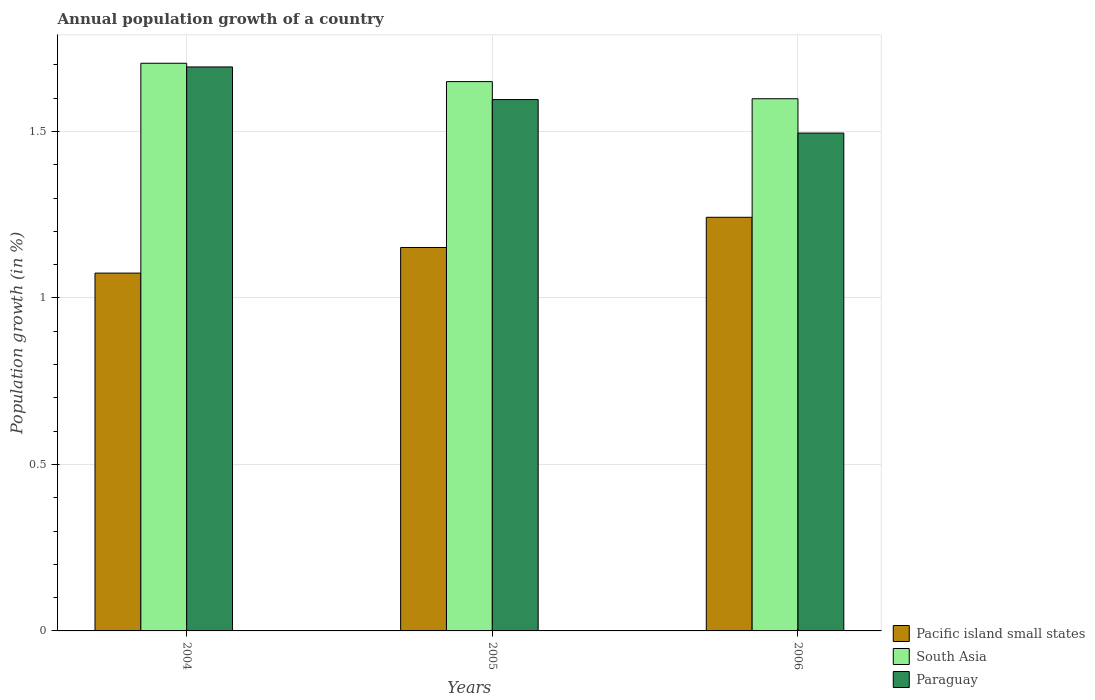How many groups of bars are there?
Make the answer very short. 3. Are the number of bars per tick equal to the number of legend labels?
Offer a terse response. Yes. Are the number of bars on each tick of the X-axis equal?
Your answer should be compact. Yes. How many bars are there on the 2nd tick from the left?
Offer a very short reply. 3. What is the label of the 1st group of bars from the left?
Your response must be concise. 2004. What is the annual population growth in Pacific island small states in 2005?
Keep it short and to the point. 1.15. Across all years, what is the maximum annual population growth in Pacific island small states?
Offer a very short reply. 1.24. Across all years, what is the minimum annual population growth in South Asia?
Offer a terse response. 1.6. What is the total annual population growth in Paraguay in the graph?
Keep it short and to the point. 4.78. What is the difference between the annual population growth in South Asia in 2004 and that in 2006?
Your response must be concise. 0.11. What is the difference between the annual population growth in Paraguay in 2005 and the annual population growth in Pacific island small states in 2006?
Your answer should be very brief. 0.35. What is the average annual population growth in Paraguay per year?
Keep it short and to the point. 1.59. In the year 2005, what is the difference between the annual population growth in Pacific island small states and annual population growth in Paraguay?
Offer a terse response. -0.44. What is the ratio of the annual population growth in Paraguay in 2005 to that in 2006?
Your answer should be compact. 1.07. What is the difference between the highest and the second highest annual population growth in Paraguay?
Your response must be concise. 0.1. What is the difference between the highest and the lowest annual population growth in Pacific island small states?
Offer a very short reply. 0.17. In how many years, is the annual population growth in Paraguay greater than the average annual population growth in Paraguay taken over all years?
Make the answer very short. 2. Is the sum of the annual population growth in Paraguay in 2004 and 2005 greater than the maximum annual population growth in Pacific island small states across all years?
Make the answer very short. Yes. What does the 3rd bar from the left in 2006 represents?
Offer a terse response. Paraguay. Is it the case that in every year, the sum of the annual population growth in South Asia and annual population growth in Paraguay is greater than the annual population growth in Pacific island small states?
Your response must be concise. Yes. How many bars are there?
Offer a terse response. 9. Are all the bars in the graph horizontal?
Provide a short and direct response. No. How many years are there in the graph?
Offer a terse response. 3. Where does the legend appear in the graph?
Offer a terse response. Bottom right. How are the legend labels stacked?
Your response must be concise. Vertical. What is the title of the graph?
Make the answer very short. Annual population growth of a country. What is the label or title of the X-axis?
Offer a terse response. Years. What is the label or title of the Y-axis?
Keep it short and to the point. Population growth (in %). What is the Population growth (in %) in Pacific island small states in 2004?
Your answer should be compact. 1.07. What is the Population growth (in %) of South Asia in 2004?
Your answer should be very brief. 1.7. What is the Population growth (in %) in Paraguay in 2004?
Your answer should be very brief. 1.69. What is the Population growth (in %) in Pacific island small states in 2005?
Give a very brief answer. 1.15. What is the Population growth (in %) of South Asia in 2005?
Your answer should be compact. 1.65. What is the Population growth (in %) in Paraguay in 2005?
Give a very brief answer. 1.6. What is the Population growth (in %) in Pacific island small states in 2006?
Ensure brevity in your answer.  1.24. What is the Population growth (in %) in South Asia in 2006?
Give a very brief answer. 1.6. What is the Population growth (in %) in Paraguay in 2006?
Give a very brief answer. 1.5. Across all years, what is the maximum Population growth (in %) in Pacific island small states?
Your answer should be compact. 1.24. Across all years, what is the maximum Population growth (in %) in South Asia?
Provide a succinct answer. 1.7. Across all years, what is the maximum Population growth (in %) in Paraguay?
Offer a terse response. 1.69. Across all years, what is the minimum Population growth (in %) in Pacific island small states?
Offer a terse response. 1.07. Across all years, what is the minimum Population growth (in %) in South Asia?
Offer a very short reply. 1.6. Across all years, what is the minimum Population growth (in %) of Paraguay?
Your answer should be compact. 1.5. What is the total Population growth (in %) of Pacific island small states in the graph?
Provide a succinct answer. 3.47. What is the total Population growth (in %) in South Asia in the graph?
Your answer should be compact. 4.95. What is the total Population growth (in %) of Paraguay in the graph?
Provide a succinct answer. 4.78. What is the difference between the Population growth (in %) in Pacific island small states in 2004 and that in 2005?
Give a very brief answer. -0.08. What is the difference between the Population growth (in %) in South Asia in 2004 and that in 2005?
Provide a succinct answer. 0.06. What is the difference between the Population growth (in %) in Paraguay in 2004 and that in 2005?
Offer a very short reply. 0.1. What is the difference between the Population growth (in %) in Pacific island small states in 2004 and that in 2006?
Offer a very short reply. -0.17. What is the difference between the Population growth (in %) in South Asia in 2004 and that in 2006?
Give a very brief answer. 0.11. What is the difference between the Population growth (in %) in Paraguay in 2004 and that in 2006?
Ensure brevity in your answer.  0.2. What is the difference between the Population growth (in %) of Pacific island small states in 2005 and that in 2006?
Provide a succinct answer. -0.09. What is the difference between the Population growth (in %) in South Asia in 2005 and that in 2006?
Keep it short and to the point. 0.05. What is the difference between the Population growth (in %) in Paraguay in 2005 and that in 2006?
Your response must be concise. 0.1. What is the difference between the Population growth (in %) of Pacific island small states in 2004 and the Population growth (in %) of South Asia in 2005?
Offer a terse response. -0.58. What is the difference between the Population growth (in %) of Pacific island small states in 2004 and the Population growth (in %) of Paraguay in 2005?
Ensure brevity in your answer.  -0.52. What is the difference between the Population growth (in %) in South Asia in 2004 and the Population growth (in %) in Paraguay in 2005?
Your response must be concise. 0.11. What is the difference between the Population growth (in %) in Pacific island small states in 2004 and the Population growth (in %) in South Asia in 2006?
Keep it short and to the point. -0.52. What is the difference between the Population growth (in %) in Pacific island small states in 2004 and the Population growth (in %) in Paraguay in 2006?
Keep it short and to the point. -0.42. What is the difference between the Population growth (in %) in South Asia in 2004 and the Population growth (in %) in Paraguay in 2006?
Your response must be concise. 0.21. What is the difference between the Population growth (in %) of Pacific island small states in 2005 and the Population growth (in %) of South Asia in 2006?
Your response must be concise. -0.45. What is the difference between the Population growth (in %) in Pacific island small states in 2005 and the Population growth (in %) in Paraguay in 2006?
Keep it short and to the point. -0.34. What is the difference between the Population growth (in %) in South Asia in 2005 and the Population growth (in %) in Paraguay in 2006?
Your answer should be compact. 0.15. What is the average Population growth (in %) of Pacific island small states per year?
Ensure brevity in your answer.  1.16. What is the average Population growth (in %) in South Asia per year?
Provide a short and direct response. 1.65. What is the average Population growth (in %) in Paraguay per year?
Keep it short and to the point. 1.59. In the year 2004, what is the difference between the Population growth (in %) in Pacific island small states and Population growth (in %) in South Asia?
Ensure brevity in your answer.  -0.63. In the year 2004, what is the difference between the Population growth (in %) of Pacific island small states and Population growth (in %) of Paraguay?
Provide a short and direct response. -0.62. In the year 2004, what is the difference between the Population growth (in %) of South Asia and Population growth (in %) of Paraguay?
Your answer should be very brief. 0.01. In the year 2005, what is the difference between the Population growth (in %) in Pacific island small states and Population growth (in %) in South Asia?
Ensure brevity in your answer.  -0.5. In the year 2005, what is the difference between the Population growth (in %) in Pacific island small states and Population growth (in %) in Paraguay?
Make the answer very short. -0.44. In the year 2005, what is the difference between the Population growth (in %) of South Asia and Population growth (in %) of Paraguay?
Keep it short and to the point. 0.05. In the year 2006, what is the difference between the Population growth (in %) in Pacific island small states and Population growth (in %) in South Asia?
Provide a succinct answer. -0.36. In the year 2006, what is the difference between the Population growth (in %) of Pacific island small states and Population growth (in %) of Paraguay?
Ensure brevity in your answer.  -0.25. In the year 2006, what is the difference between the Population growth (in %) in South Asia and Population growth (in %) in Paraguay?
Your answer should be very brief. 0.1. What is the ratio of the Population growth (in %) in Pacific island small states in 2004 to that in 2005?
Offer a very short reply. 0.93. What is the ratio of the Population growth (in %) in South Asia in 2004 to that in 2005?
Offer a terse response. 1.03. What is the ratio of the Population growth (in %) of Paraguay in 2004 to that in 2005?
Your answer should be very brief. 1.06. What is the ratio of the Population growth (in %) in Pacific island small states in 2004 to that in 2006?
Keep it short and to the point. 0.87. What is the ratio of the Population growth (in %) of South Asia in 2004 to that in 2006?
Keep it short and to the point. 1.07. What is the ratio of the Population growth (in %) in Paraguay in 2004 to that in 2006?
Your response must be concise. 1.13. What is the ratio of the Population growth (in %) in Pacific island small states in 2005 to that in 2006?
Your answer should be compact. 0.93. What is the ratio of the Population growth (in %) of South Asia in 2005 to that in 2006?
Keep it short and to the point. 1.03. What is the ratio of the Population growth (in %) in Paraguay in 2005 to that in 2006?
Give a very brief answer. 1.07. What is the difference between the highest and the second highest Population growth (in %) in Pacific island small states?
Offer a very short reply. 0.09. What is the difference between the highest and the second highest Population growth (in %) in South Asia?
Provide a succinct answer. 0.06. What is the difference between the highest and the second highest Population growth (in %) of Paraguay?
Your answer should be very brief. 0.1. What is the difference between the highest and the lowest Population growth (in %) in Pacific island small states?
Provide a succinct answer. 0.17. What is the difference between the highest and the lowest Population growth (in %) in South Asia?
Keep it short and to the point. 0.11. What is the difference between the highest and the lowest Population growth (in %) in Paraguay?
Make the answer very short. 0.2. 